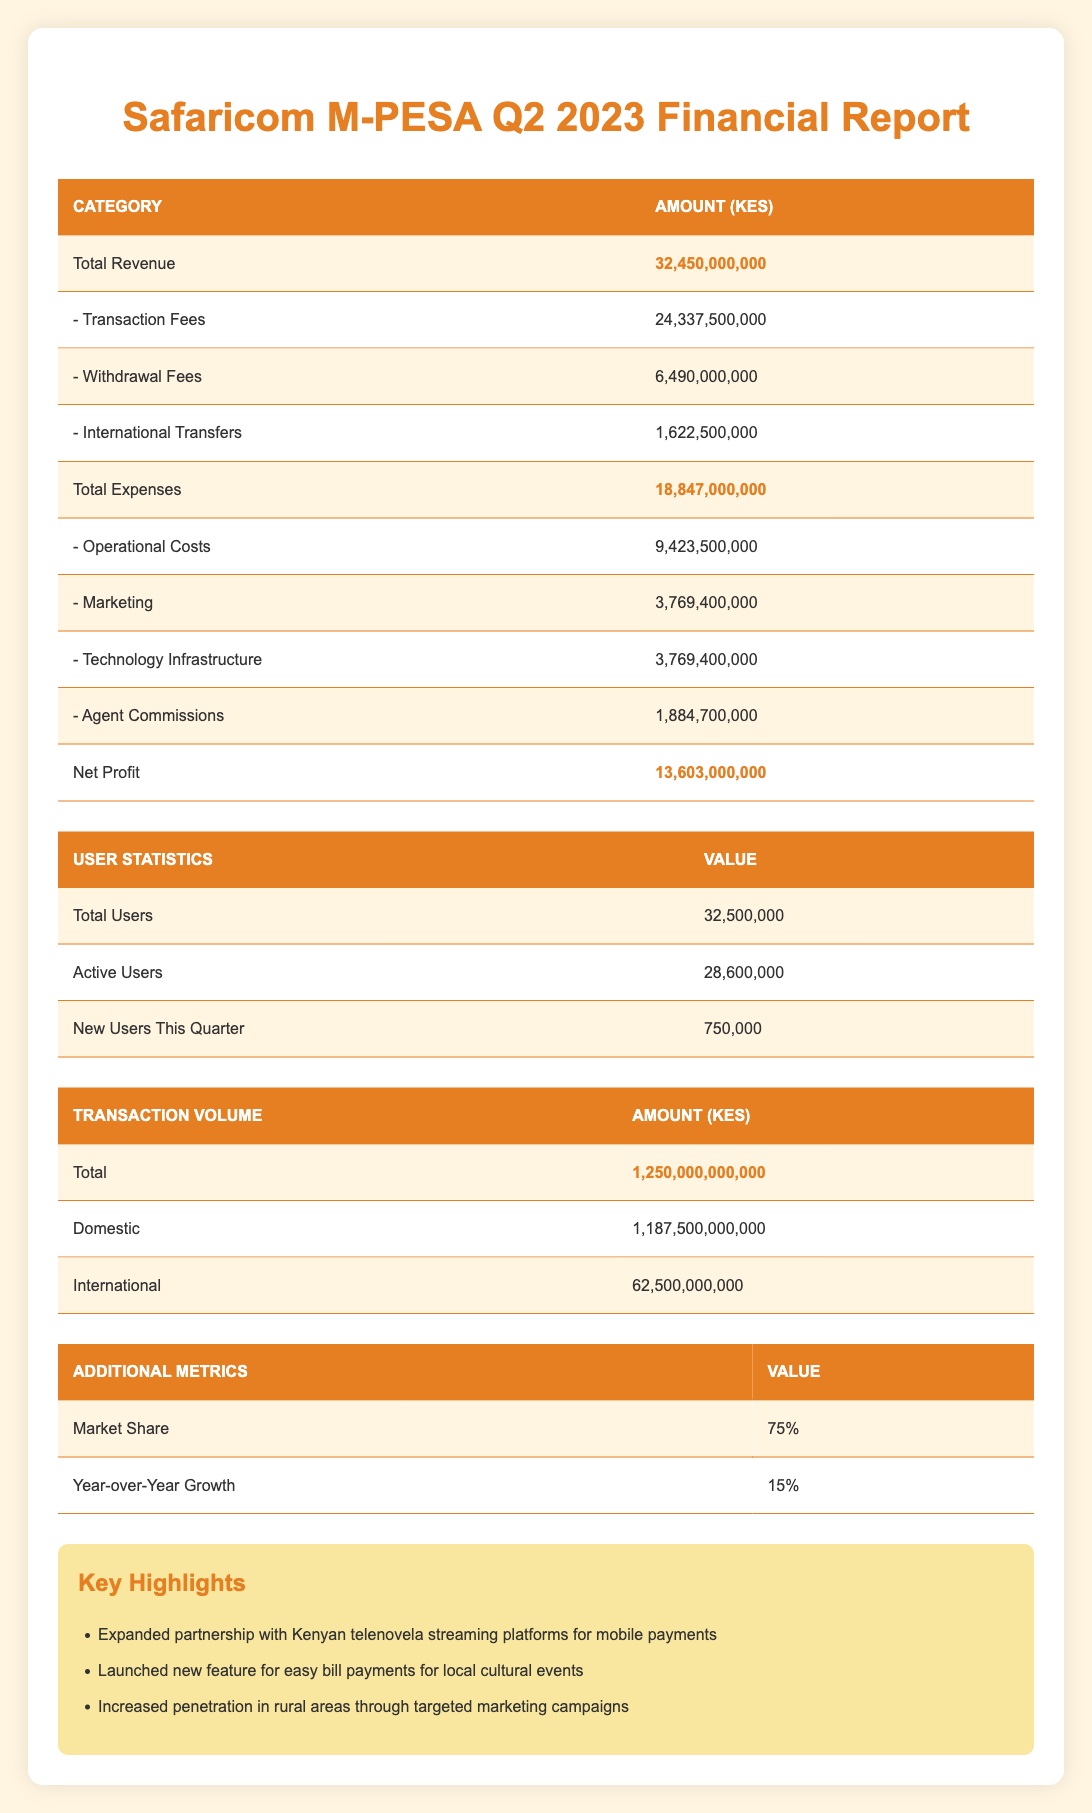What is the total revenue for Safaricom M-PESA in Q2 2023? The total revenue is found directly in the revenue section of the table, which shows a value of 32,450,000,000 KES.
Answer: 32,450,000,000 KES How much did Safaricom M-PESA earn from transaction fees in Q2 2023? The transaction fees are listed as part of the revenue breakdown. The value given is 24,337,500,000 KES.
Answer: 24,337,500,000 KES What are the total expenses incurred by Safaricom M-PESA in Q2 2023? The total expenses amount is presented in the expenses section of the table, which is 18,847,000,000 KES.
Answer: 18,847,000,000 KES Is the net profit greater than 13 billion KES? The net profit reported in the table is 13,603,000,000 KES. Since 13,603,000,000 KES is indeed greater than 13,000,000,000 KES, the answer is yes.
Answer: Yes What is the combined amount of operational costs and marketing expenses? The operational costs amount to 9,423,500,000 KES and marketing expenses are 3,769,400,000 KES. Adding these two gives us 9,423,500,000 + 3,769,400,000 = 13,192,900,000 KES.
Answer: 13,192,900,000 KES How many new users were reported for Q2 2023? The table specifies that Safaricom M-PESA gained 750,000 new users this quarter, which is directly stated in the user statistics section.
Answer: 750,000 What is the percentage of active users compared to total users for Safaricom M-PESA? The active users are 28,600,000 and total users are 32,500,000. The percentage is calculated as (28,600,000 / 32,500,000) * 100 = approximately 88%.
Answer: 88% Did Safaricom M-PESA see an increase in year-over-year growth compared to the previous year? The year-over-year growth listed in the table is 15%, indicating an increase from the previous year. Thus, the answer is yes.
Answer: Yes What is the total volume of domestic transactions for Safaricom M-PESA? The table specifies that the total volume for domestic transactions is 1,187,500,000,000 KES, which is directly provided in the transaction volume section.
Answer: 1,187,500,000,000 KES 